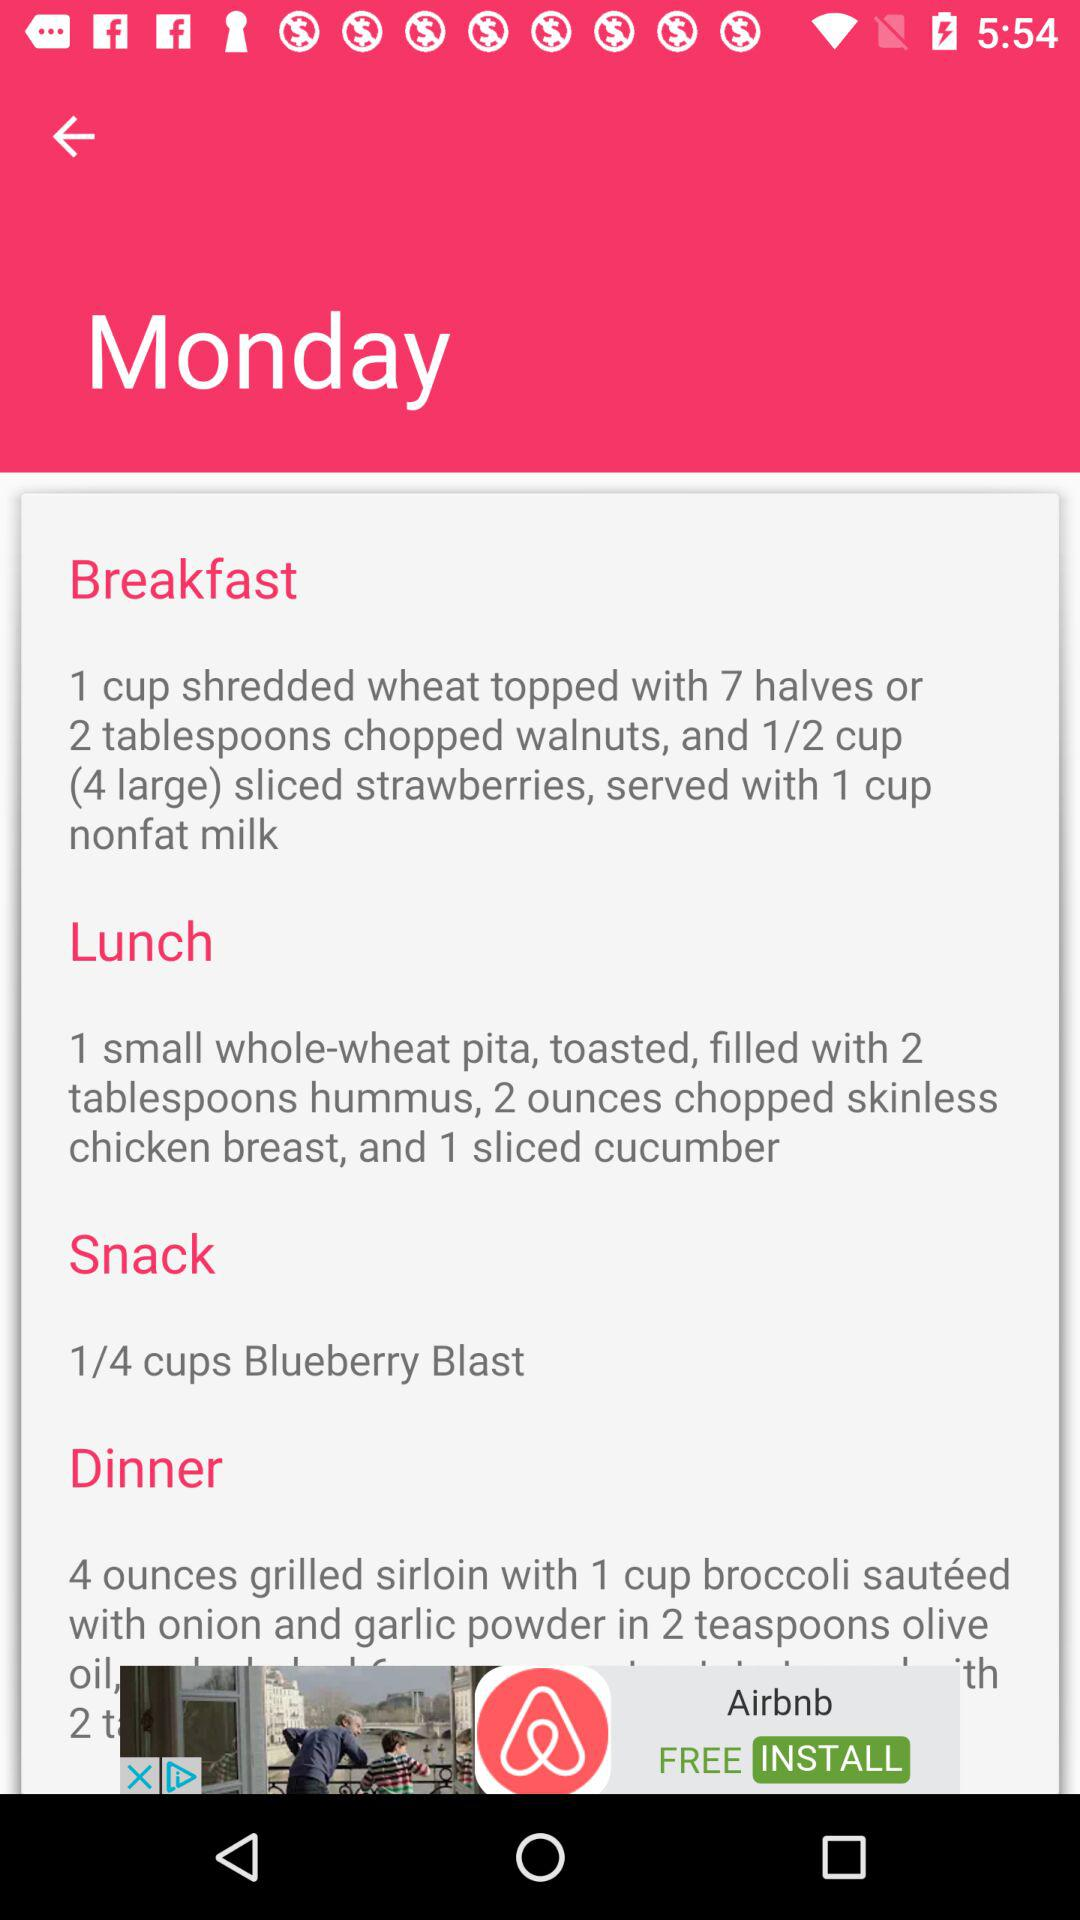How much chopped, skinless chicken breast do we need for lunch? You need 2 ounces of chopped, skinless chicken breast for lunch. 